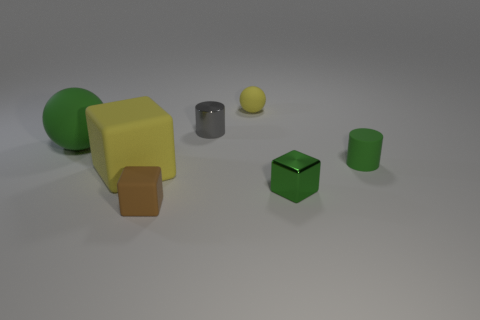There is a rubber thing that is the same color as the matte cylinder; what is its size?
Your response must be concise. Large. There is a large yellow block; what number of large yellow blocks are left of it?
Provide a short and direct response. 0. Is the material of the yellow object in front of the yellow matte ball the same as the large ball?
Offer a very short reply. Yes. There is another metallic thing that is the same shape as the large yellow thing; what is its color?
Your answer should be very brief. Green. What is the shape of the tiny gray object?
Make the answer very short. Cylinder. How many objects are big purple cubes or large green objects?
Your response must be concise. 1. There is a ball behind the small gray metallic thing; is its color the same as the big rubber thing that is in front of the large green object?
Offer a terse response. Yes. How many other objects are the same shape as the tiny yellow thing?
Your answer should be compact. 1. Are there any big metallic spheres?
Provide a short and direct response. No. How many objects are either small green objects or small shiny objects that are on the left side of the small yellow matte sphere?
Keep it short and to the point. 3. 